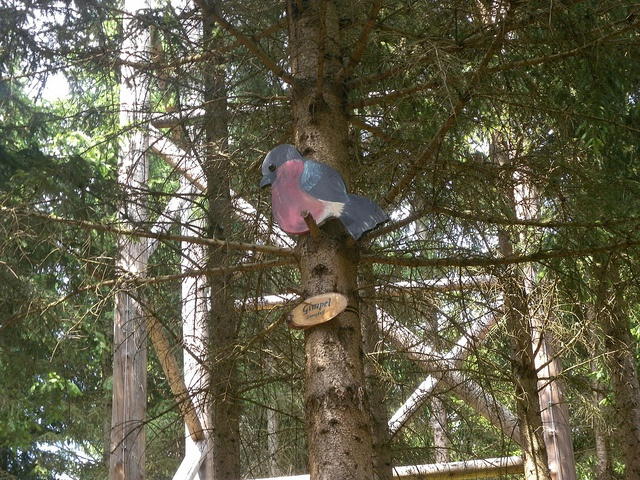Describe the objects in this image and their specific colors. I can see a bird in darkgray, gray, and salmon tones in this image. 